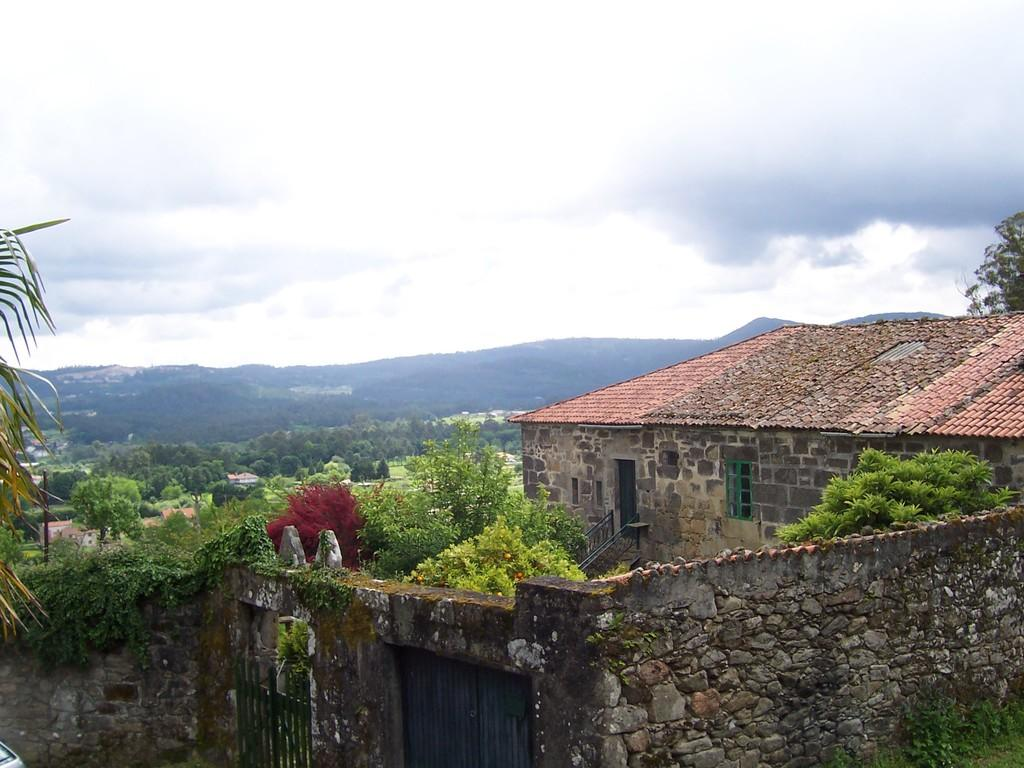What is the main structure in the center of the image? There is a building in the center of the image. What architectural features can be seen in the center of the image? There is a wall, window, roof, gate, door, and staircase in the center of the image. What type of vegetation is present in the center of the image? There are trees, plants, and grass in the center of the image. What can be seen in the background of the image? There is sky, clouds, trees, and a hill visible in the background of the image. What substance is being protested against in the image? There is no protest or substance mentioned in the image; it primarily features a building and its surroundings. 